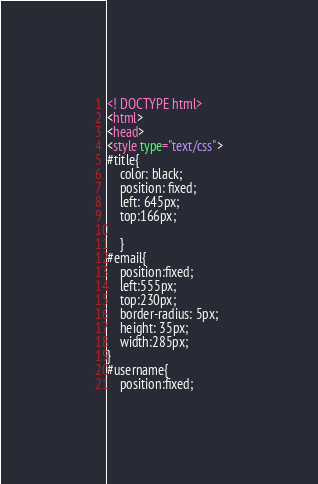Convert code to text. <code><loc_0><loc_0><loc_500><loc_500><_HTML_><! DOCTYPE html>
<html>
<head>
<style type="text/css">
#title{
	color: black;
	position: fixed;
	left: 645px;
	top:166px;
	
	}
#email{
	position:fixed;
	left:555px;
	top:230px;
	border-radius: 5px;
	height: 35px;
	width:285px;
} 
#username{
	position:fixed;</code> 